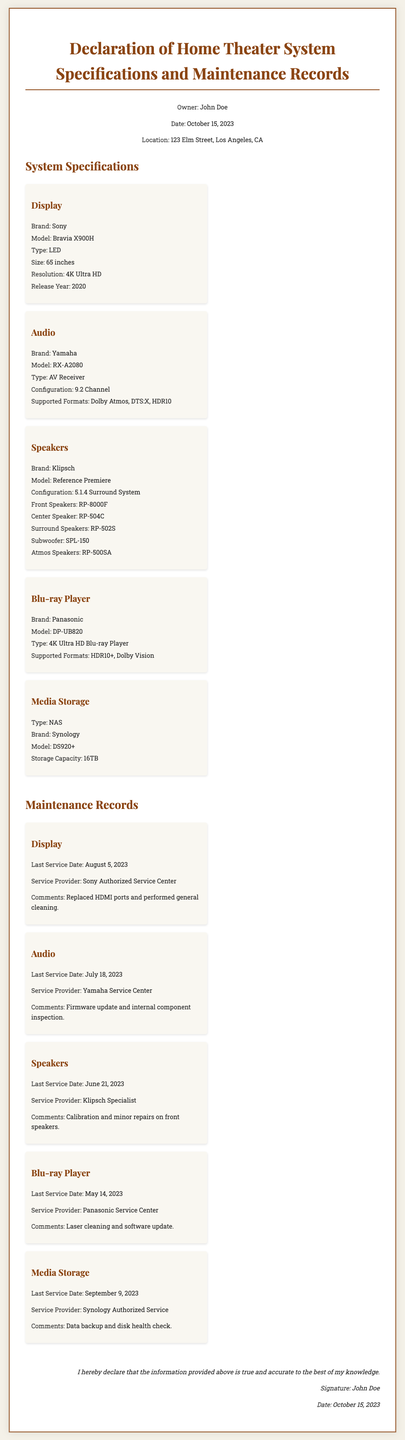What is the owner's name? The owner's name is mentioned in the header of the document.
Answer: John Doe What is the date of the declaration? The date is also specified in the header section of the document.
Answer: October 15, 2023 What is the screen size of the display? The screen size is provided in the specifications for the display section.
Answer: 65 inches What type of audio system is used? The audio system type is listed in the audio specifications section.
Answer: AV Receiver When was the last service date for the Blu-ray player? The last service date for the Blu-ray player is provided in the maintenance records section.
Answer: May 14, 2023 Which maintenance provider serviced the speakers? The service provider for the speakers is mentioned in the maintenance records section.
Answer: Klipsch Specialist What brand is the media storage system? The brand of the media storage system can be found in the specifications section.
Answer: Synology How many channels does the audio configuration support? The number of channels is specified in the audio specifications section.
Answer: 9.2 Channel What was done during the last service of the display? The comments for the display maintenance detail what was performed during the service.
Answer: Replaced HDMI ports and performed general cleaning 